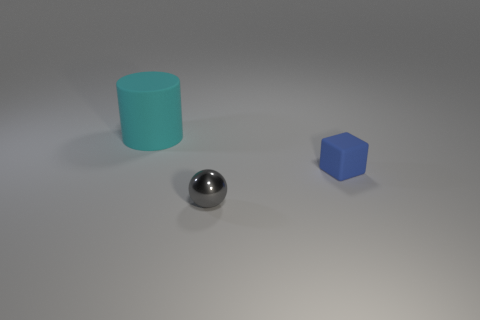Add 3 yellow matte cubes. How many objects exist? 6 Subtract all blocks. How many objects are left? 2 Subtract all rubber blocks. Subtract all brown spheres. How many objects are left? 2 Add 3 blue objects. How many blue objects are left? 4 Add 2 red cylinders. How many red cylinders exist? 2 Subtract 0 green cylinders. How many objects are left? 3 